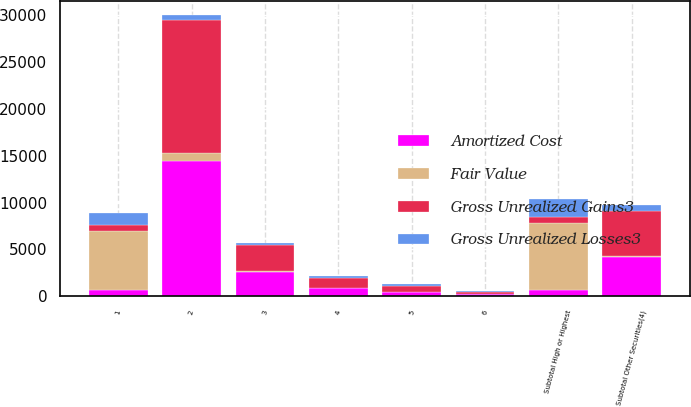Convert chart to OTSL. <chart><loc_0><loc_0><loc_500><loc_500><stacked_bar_chart><ecel><fcel>1<fcel>2<fcel>Subtotal High or Highest<fcel>3<fcel>4<fcel>5<fcel>6<fcel>Subtotal Other Securities(4)<nl><fcel>Gross Unrealized Gains3<fcel>672<fcel>14129<fcel>672<fcel>2753<fcel>1067<fcel>630<fcel>271<fcel>4721<nl><fcel>Fair Value<fcel>6278<fcel>892<fcel>7170<fcel>100<fcel>24<fcel>21<fcel>28<fcel>173<nl><fcel>Gross Unrealized Losses3<fcel>1240<fcel>585<fcel>1825<fcel>208<fcel>206<fcel>211<fcel>89<fcel>714<nl><fcel>Amortized Cost<fcel>672<fcel>14436<fcel>672<fcel>2645<fcel>885<fcel>440<fcel>210<fcel>4180<nl></chart> 